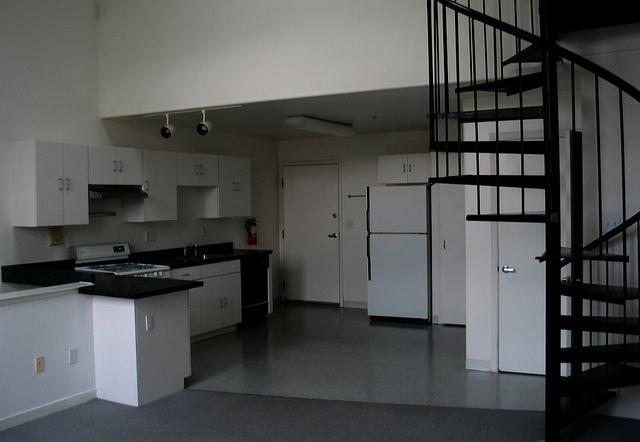How many trash cans are there?
Quick response, please. 0. What is this room called?
Concise answer only. Kitchen. Are their hinges on the railing?
Be succinct. No. Is it sunny?
Give a very brief answer. No. Where does the stairway lead?
Short answer required. Up. What color is the pipe?
Give a very brief answer. Black. What kind of lighting is shown?
Short answer required. Track. Is there a microwave oven?
Answer briefly. No. How many rungs are in the ladder?
Be succinct. 10. 